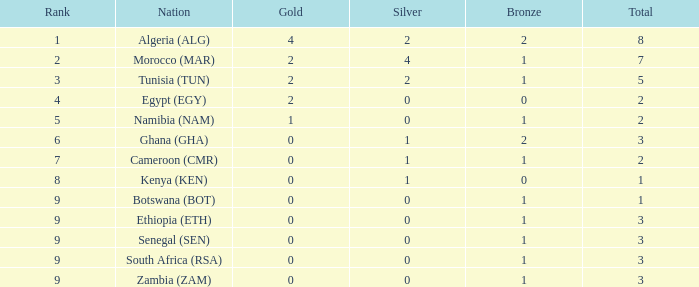What is the aggregate number of silver with a total below 1? 0.0. 